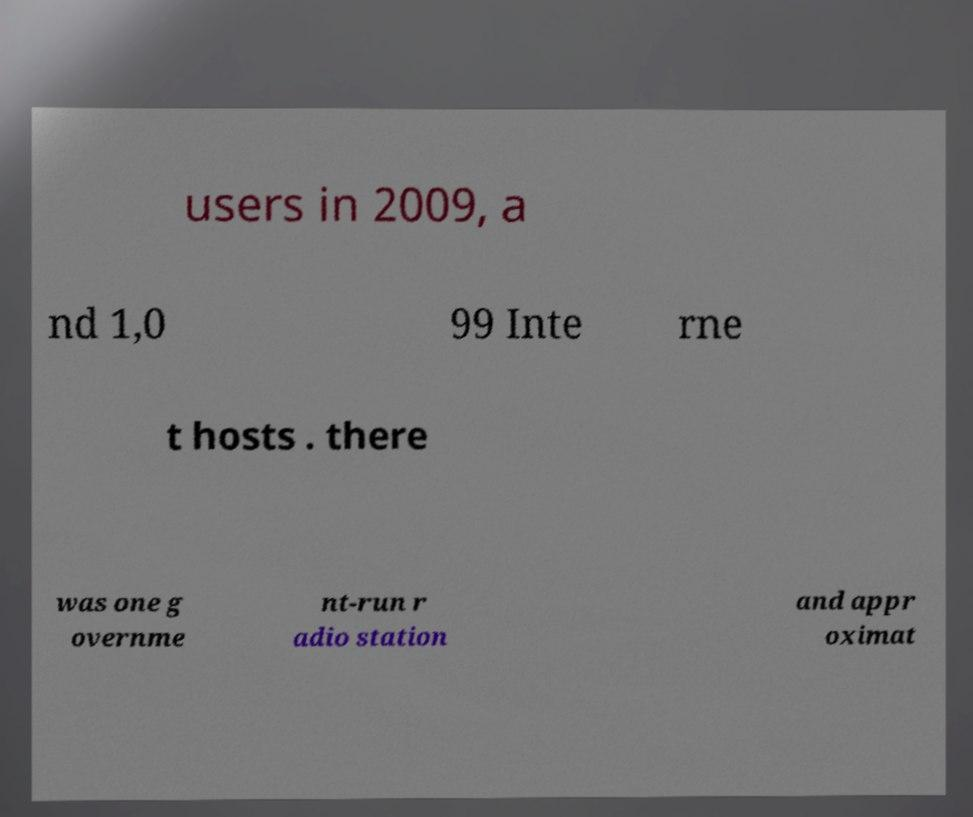Could you extract and type out the text from this image? users in 2009, a nd 1,0 99 Inte rne t hosts . there was one g overnme nt-run r adio station and appr oximat 